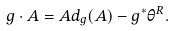<formula> <loc_0><loc_0><loc_500><loc_500>g \cdot A = A d _ { g } ( A ) - g ^ { * } \theta ^ { R } .</formula> 